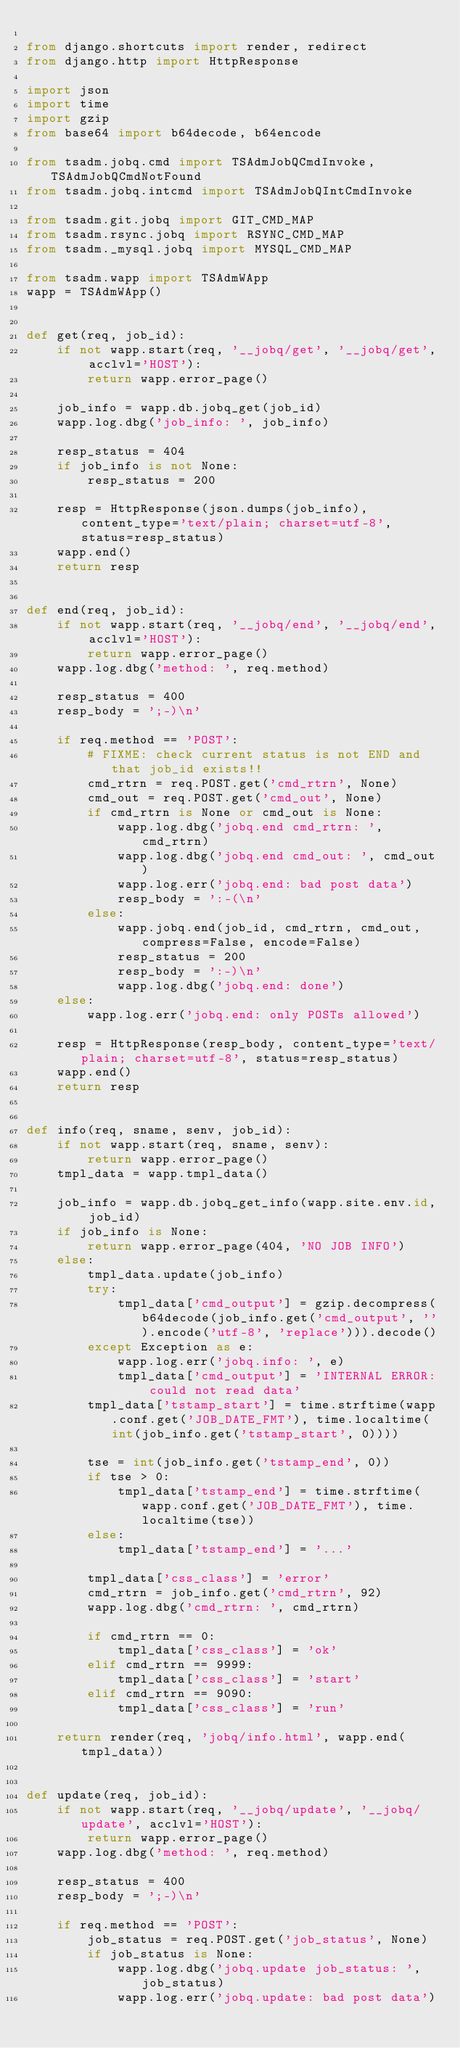Convert code to text. <code><loc_0><loc_0><loc_500><loc_500><_Python_>
from django.shortcuts import render, redirect
from django.http import HttpResponse

import json
import time
import gzip
from base64 import b64decode, b64encode

from tsadm.jobq.cmd import TSAdmJobQCmdInvoke, TSAdmJobQCmdNotFound
from tsadm.jobq.intcmd import TSAdmJobQIntCmdInvoke

from tsadm.git.jobq import GIT_CMD_MAP
from tsadm.rsync.jobq import RSYNC_CMD_MAP
from tsadm._mysql.jobq import MYSQL_CMD_MAP

from tsadm.wapp import TSAdmWApp
wapp = TSAdmWApp()


def get(req, job_id):
    if not wapp.start(req, '__jobq/get', '__jobq/get', acclvl='HOST'):
        return wapp.error_page()

    job_info = wapp.db.jobq_get(job_id)
    wapp.log.dbg('job_info: ', job_info)

    resp_status = 404
    if job_info is not None:
        resp_status = 200

    resp = HttpResponse(json.dumps(job_info), content_type='text/plain; charset=utf-8', status=resp_status)
    wapp.end()
    return resp


def end(req, job_id):
    if not wapp.start(req, '__jobq/end', '__jobq/end', acclvl='HOST'):
        return wapp.error_page()
    wapp.log.dbg('method: ', req.method)

    resp_status = 400
    resp_body = ';-)\n'

    if req.method == 'POST':
        # FIXME: check current status is not END and that job_id exists!!
        cmd_rtrn = req.POST.get('cmd_rtrn', None)
        cmd_out = req.POST.get('cmd_out', None)
        if cmd_rtrn is None or cmd_out is None:
            wapp.log.dbg('jobq.end cmd_rtrn: ', cmd_rtrn)
            wapp.log.dbg('jobq.end cmd_out: ', cmd_out)
            wapp.log.err('jobq.end: bad post data')
            resp_body = ':-(\n'
        else:
            wapp.jobq.end(job_id, cmd_rtrn, cmd_out, compress=False, encode=False)
            resp_status = 200
            resp_body = ':-)\n'
            wapp.log.dbg('jobq.end: done')
    else:
        wapp.log.err('jobq.end: only POSTs allowed')

    resp = HttpResponse(resp_body, content_type='text/plain; charset=utf-8', status=resp_status)
    wapp.end()
    return resp


def info(req, sname, senv, job_id):
    if not wapp.start(req, sname, senv):
        return wapp.error_page()
    tmpl_data = wapp.tmpl_data()

    job_info = wapp.db.jobq_get_info(wapp.site.env.id, job_id)
    if job_info is None:
        return wapp.error_page(404, 'NO JOB INFO')
    else:
        tmpl_data.update(job_info)
        try:
            tmpl_data['cmd_output'] = gzip.decompress(b64decode(job_info.get('cmd_output', '').encode('utf-8', 'replace'))).decode()
        except Exception as e:
            wapp.log.err('jobq.info: ', e)
            tmpl_data['cmd_output'] = 'INTERNAL ERROR: could not read data'
        tmpl_data['tstamp_start'] = time.strftime(wapp.conf.get('JOB_DATE_FMT'), time.localtime(int(job_info.get('tstamp_start', 0))))

        tse = int(job_info.get('tstamp_end', 0))
        if tse > 0:
            tmpl_data['tstamp_end'] = time.strftime(wapp.conf.get('JOB_DATE_FMT'), time.localtime(tse))
        else:
            tmpl_data['tstamp_end'] = '...'

        tmpl_data['css_class'] = 'error'
        cmd_rtrn = job_info.get('cmd_rtrn', 92)
        wapp.log.dbg('cmd_rtrn: ', cmd_rtrn)

        if cmd_rtrn == 0:
            tmpl_data['css_class'] = 'ok'
        elif cmd_rtrn == 9999:
            tmpl_data['css_class'] = 'start'
        elif cmd_rtrn == 9090:
            tmpl_data['css_class'] = 'run'

    return render(req, 'jobq/info.html', wapp.end(tmpl_data))


def update(req, job_id):
    if not wapp.start(req, '__jobq/update', '__jobq/update', acclvl='HOST'):
        return wapp.error_page()
    wapp.log.dbg('method: ', req.method)

    resp_status = 400
    resp_body = ';-)\n'

    if req.method == 'POST':
        job_status = req.POST.get('job_status', None)
        if job_status is None:
            wapp.log.dbg('jobq.update job_status: ', job_status)
            wapp.log.err('jobq.update: bad post data')</code> 